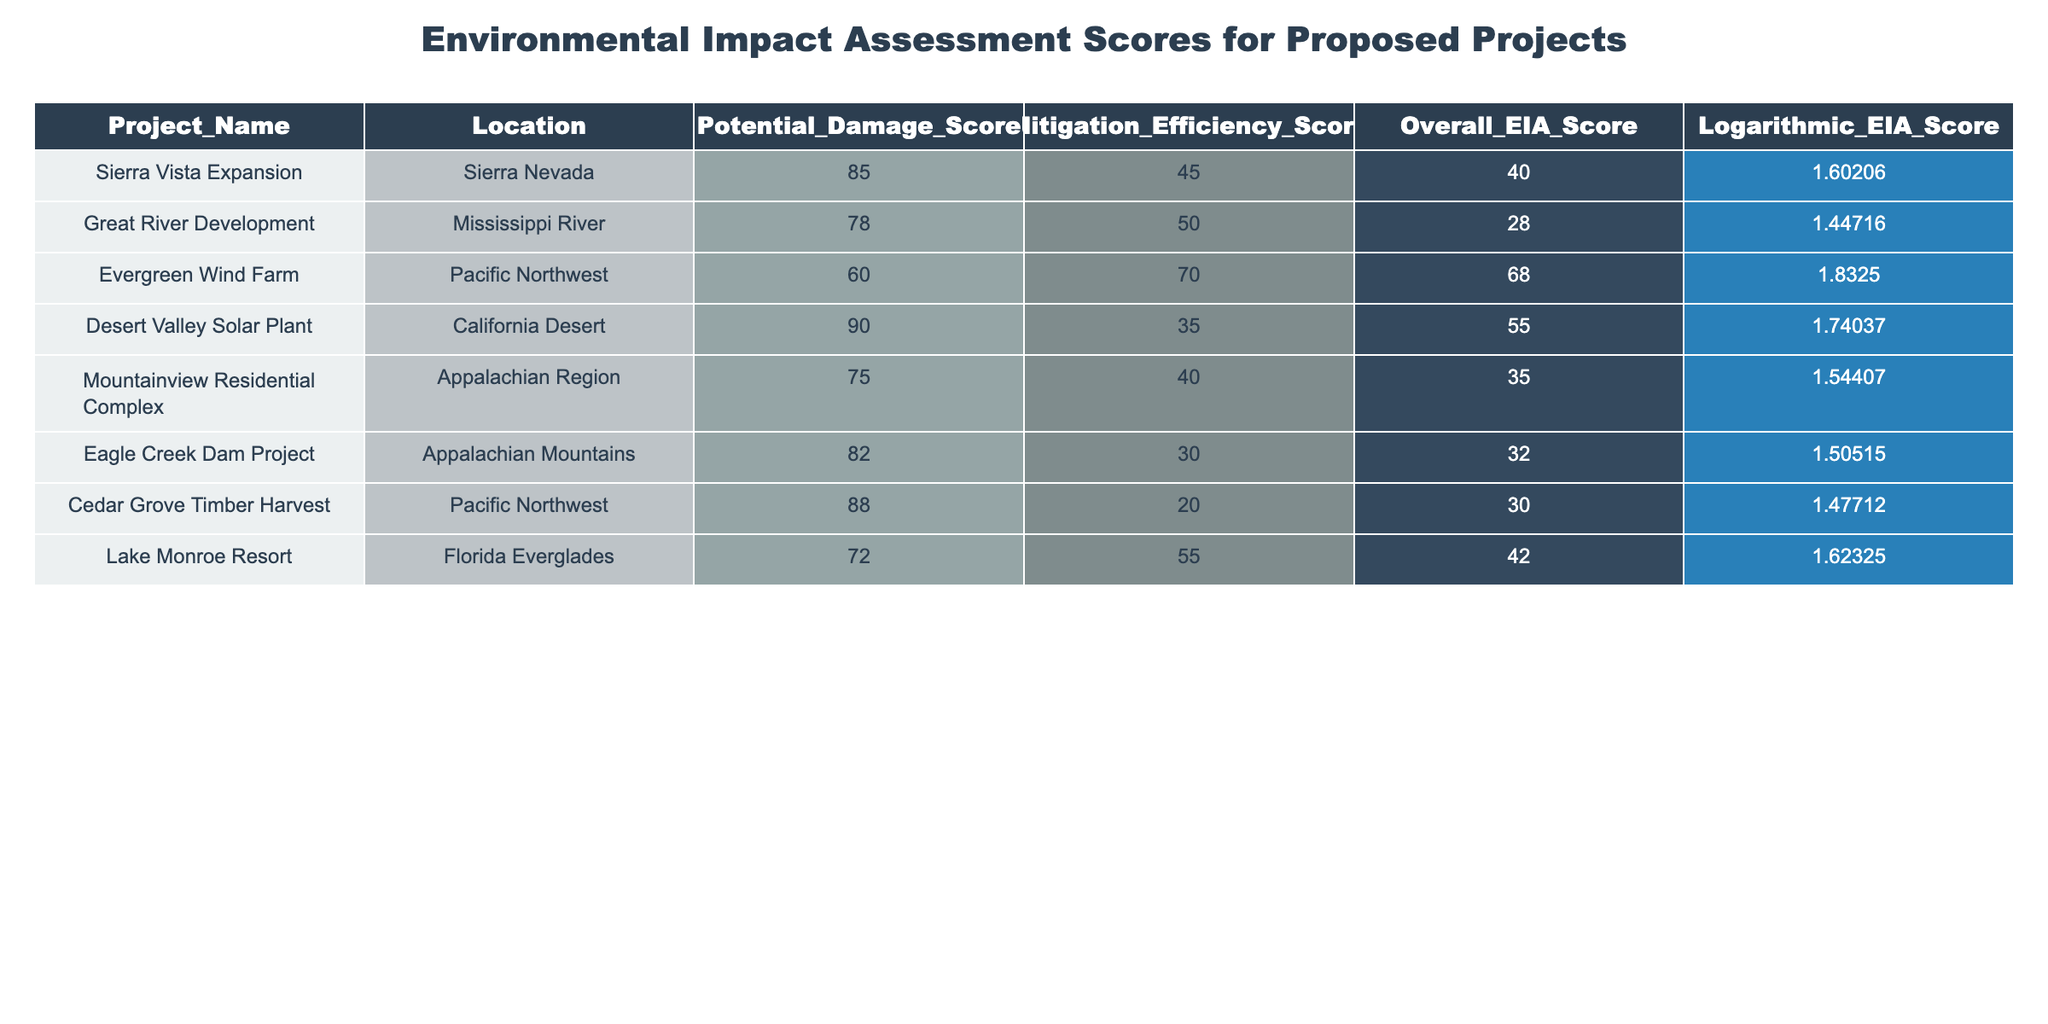What is the Overall EIA Score for the Eagle Creek Dam Project? The Overall EIA Score for the Eagle Creek Dam Project can be found directly in the table under the corresponding row. The score listed is 32.
Answer: 32 Which project has the highest Potential Damage Score and what is that score? By examining the Potential Damage Score column, the project with the highest score is the Desert Valley Solar Plant, with a score of 90.
Answer: 90 Is the Mitigation Efficiency Score for the Evergreen Wind Farm higher than the Lake Monroe Resort? Looking at the Mitigation Efficiency Scores, the Evergreen Wind Farm has a score of 70, while the Lake Monroe Resort has a score of 55. Therefore, yes, the Evergreen Wind Farm's score is higher.
Answer: Yes What is the average Overall EIA Score for all the projects listed? To find the average, we first sum up all the Overall EIA Scores: 40 + 28 + 68 + 55 + 35 + 32 + 30 + 42 = 330. There are 8 projects, so the average is 330 / 8 = 41.25.
Answer: 41.25 Which project has the lowest Logarithmic EIA Score, and what is that score? In the Logarithmic EIA Score column, the lowest value can be found. The Eagle Creek Dam Project has the lowest score of 1.50515.
Answer: 1.50515 What is the difference between the Potential Damage Score of the Desert Valley Solar Plant and the Mountainview Residential Complex? The Potential Damage Score for Desert Valley Solar Plant is 90, and for Mountainview Residential Complex, it is 75. The difference is 90 - 75 = 15.
Answer: 15 How many projects have a Mitigation Efficiency Score below 40? By reviewing the Mitigation Efficiency Scores, we see that the projects with scores below 40 are the Cedar Grove Timber Harvest (20), Eagle Creek Dam Project (30), and Mountainview Residential Complex (40). Therefore, there are 3 projects.
Answer: 3 What is the overall highest score among the Overall EIA Scores for all projects? Reviewing the Overall EIA Scores, the highest score is 68, from the Evergreen Wind Farm.
Answer: 68 Are there more projects with an Overall EIA Score above 40 or below 40? By counting the Overall EIA Scores, the projects above 40 are Sierra Vista Expansion, Evergreen Wind Farm, Desert Valley Solar Plant, and Lake Monroe Resort, totaling 4. The projects below 40 are Great River Development, Mountainview Residential Complex, Eagle Creek Dam Project, and Cedar Grove Timber Harvest, totaling 4. Therefore, there is no difference; the count is equal.
Answer: Equal 